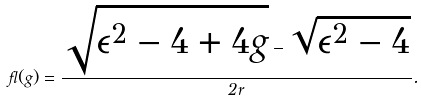<formula> <loc_0><loc_0><loc_500><loc_500>\gamma ( g ) = \frac { \sqrt { \epsilon ^ { 2 } - 4 + 4 g } - \sqrt { \epsilon ^ { 2 } - 4 } } { 2 r } .</formula> 